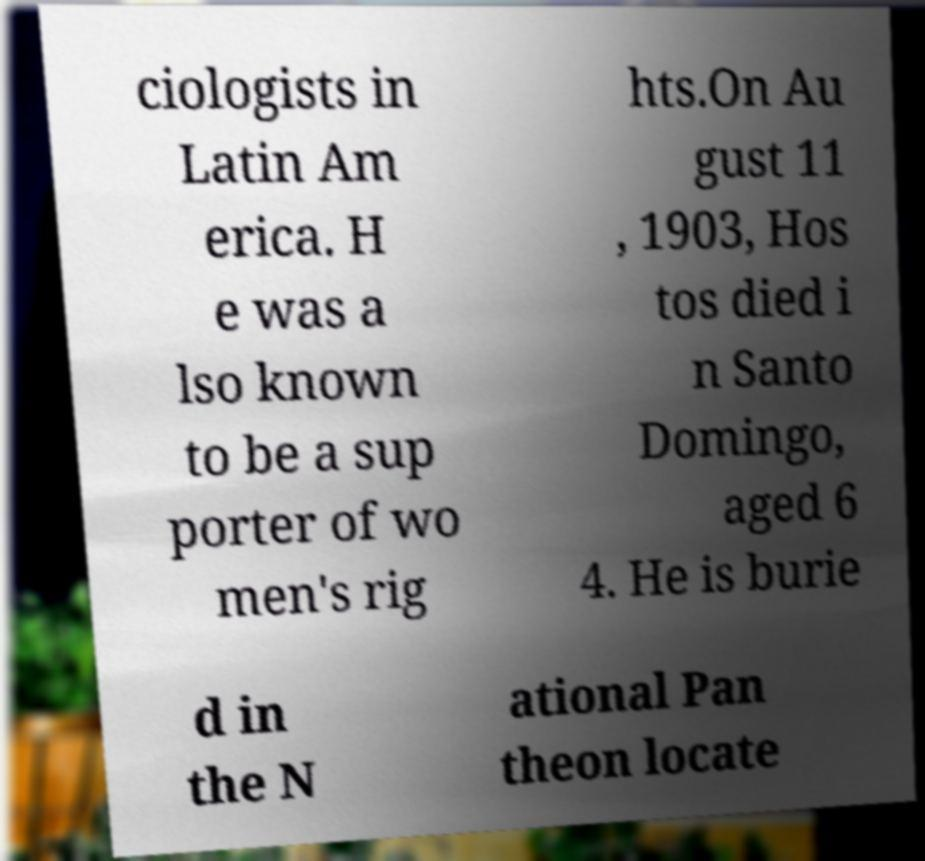Can you read and provide the text displayed in the image?This photo seems to have some interesting text. Can you extract and type it out for me? ciologists in Latin Am erica. H e was a lso known to be a sup porter of wo men's rig hts.On Au gust 11 , 1903, Hos tos died i n Santo Domingo, aged 6 4. He is burie d in the N ational Pan theon locate 